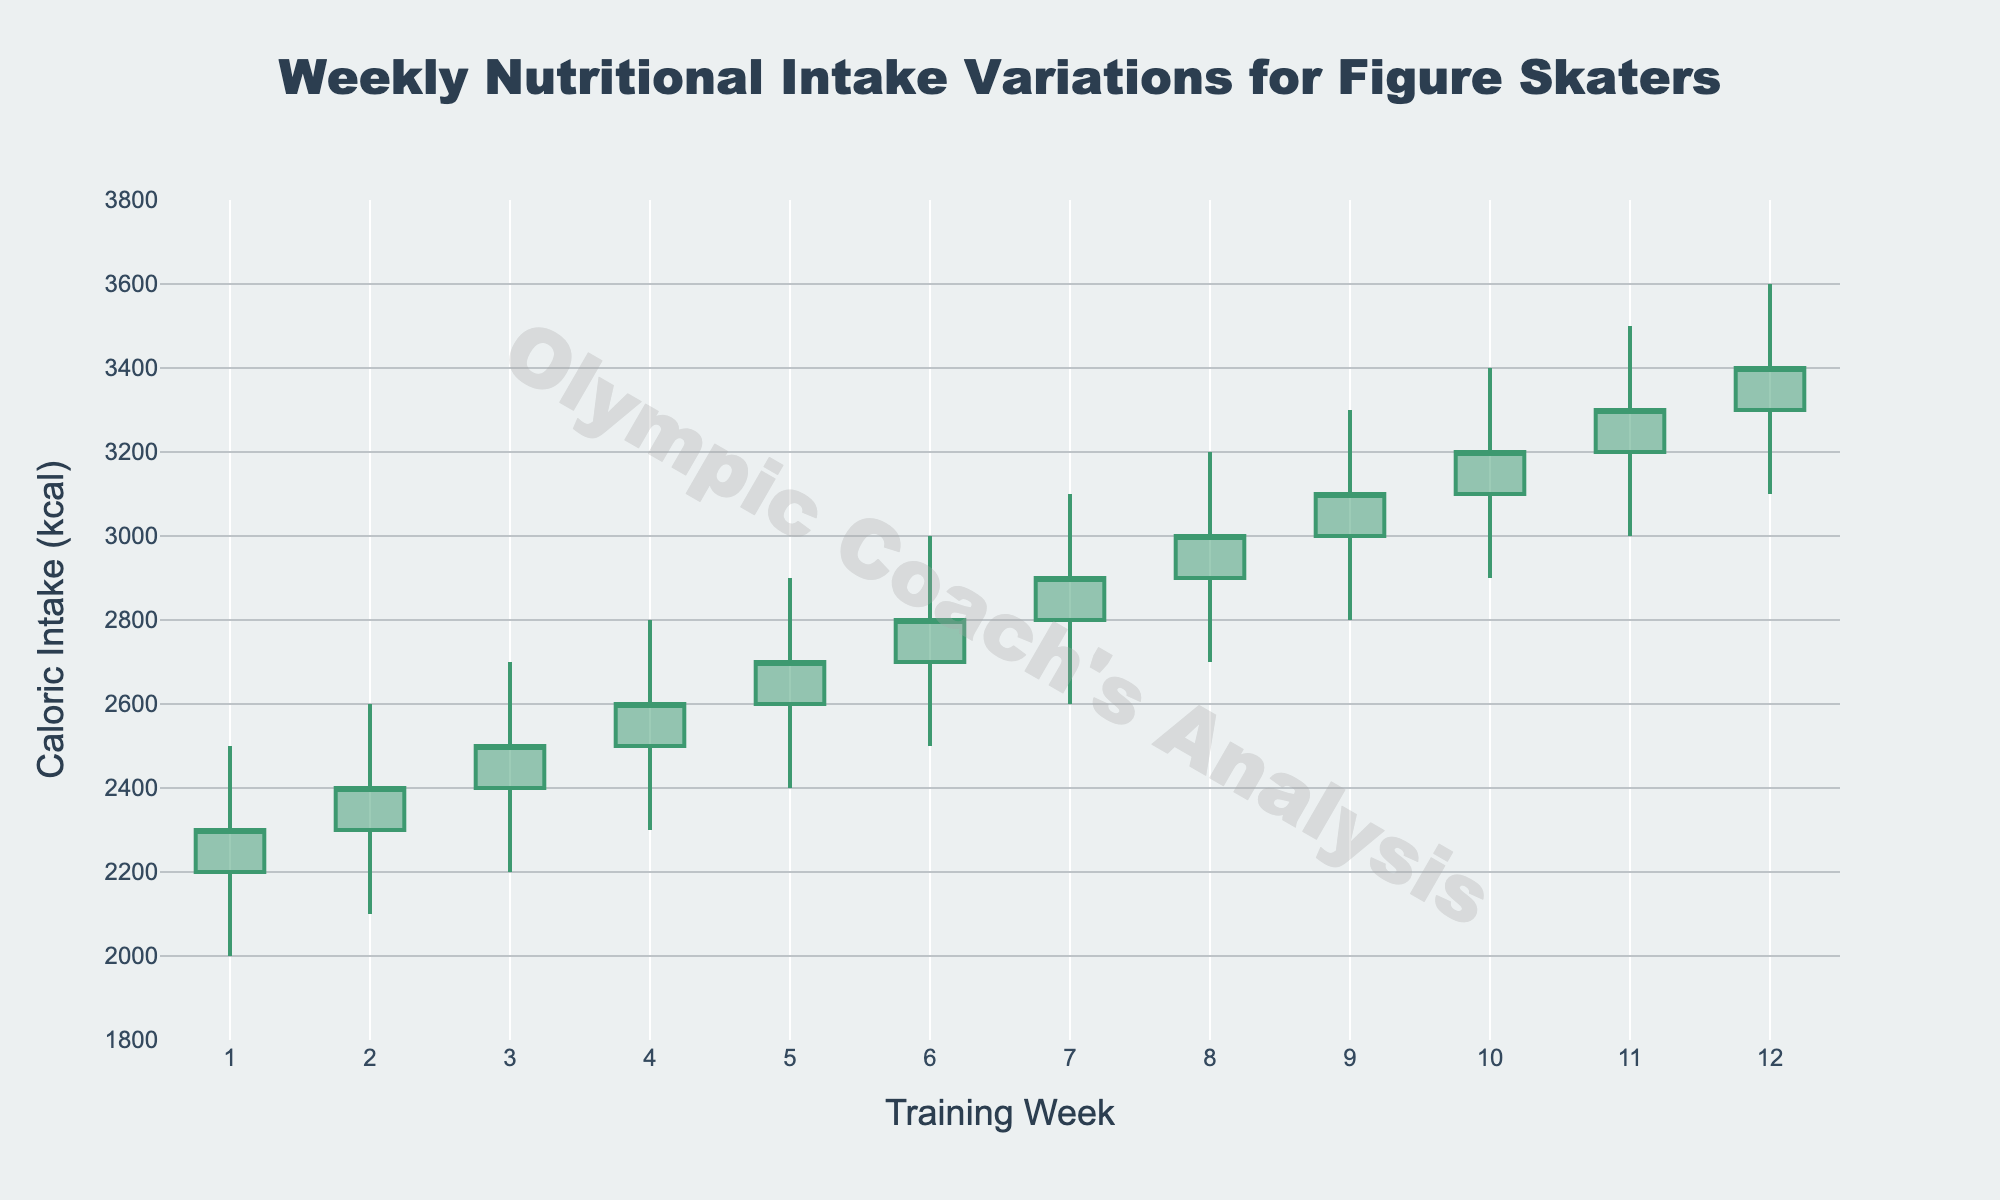What's the highest caloric intake recorded in any week? To find the highest caloric intake, check the "High" values in the chart. The highest recorded value is 3600.
Answer: 3600 In which week did the caloric intake close at 2700 kcal? Look at the "Close" values on the chart and find the corresponding week number. The intake closes at 2700 kcal in Week 5.
Answer: Week 5 How many weeks have a minimum caloric intake (Low) of at least 2500 kcal? Examine the "Low" values and count the number of weeks with a value of 2500 kcal or more. These weeks are 6 to 12, making it 7 weeks.
Answer: 7 weeks Compare the average caloric intake for the first 6 weeks and the last 6 weeks. Which period has a higher average? Calculate the average caloric intake for both periods: 
First 6 weeks: (2300 + 2400 + 2500 + 2600 + 2700 + 2800) / 6 = 2550 kcal.
Last 6 weeks: (2900 + 3000 + 3100 + 3200 + 3300 + 3400) / 6 = 3150 kcal.
The last 6 weeks have a higher average caloric intake.
Answer: Last 6 weeks What trend can be observed from the caloric intake from Week 1 to Week 12? The caloric intake shows a consistent upward trend from Week 1 (Open at 2200 kcal) to Week 12 (Close at 3400 kcal).
Answer: Upward trend Which week experienced the largest range in caloric intake values? To find the largest range, calculate the difference between the High and Low values for each week and identify the week with the maximum difference. Week 12 has the largest range: 3600 - 3100 = 500 kcal.
Answer: Week 12 If the nutritional goals are set to keep the caloric intake bounds between 2000 and 3000 kcal, how many weeks met this criterion? Count the weeks where the "High" value is less than or equal to 3000 kcal and the "Low" value is greater than or equal to 2000 kcal. Only Weeks 1 and 2 meet this criterion.
Answer: 2 weeks Did any week have a closing caloric intake higher than the highest caloric intake of the previous week? Check the closing values and compare each week’s Close value with the previous week’s High value. For example, Week 2’s Close (2400) is higher than Week 1’s High (2500), therefore this is true.
Answer: Yes What was the minimum caloric intake recorded in Week 7? Refer to the "Low" value for Week 7, which is 2600 kcal.
Answer: 2600 Compare the closing caloric intake of Week 6 and Week 7. Was there an increase or a decrease? The Close value for Week 6 is 2800 kcal and for Week 7 is 2900 kcal, showing an increase.
Answer: Increase 